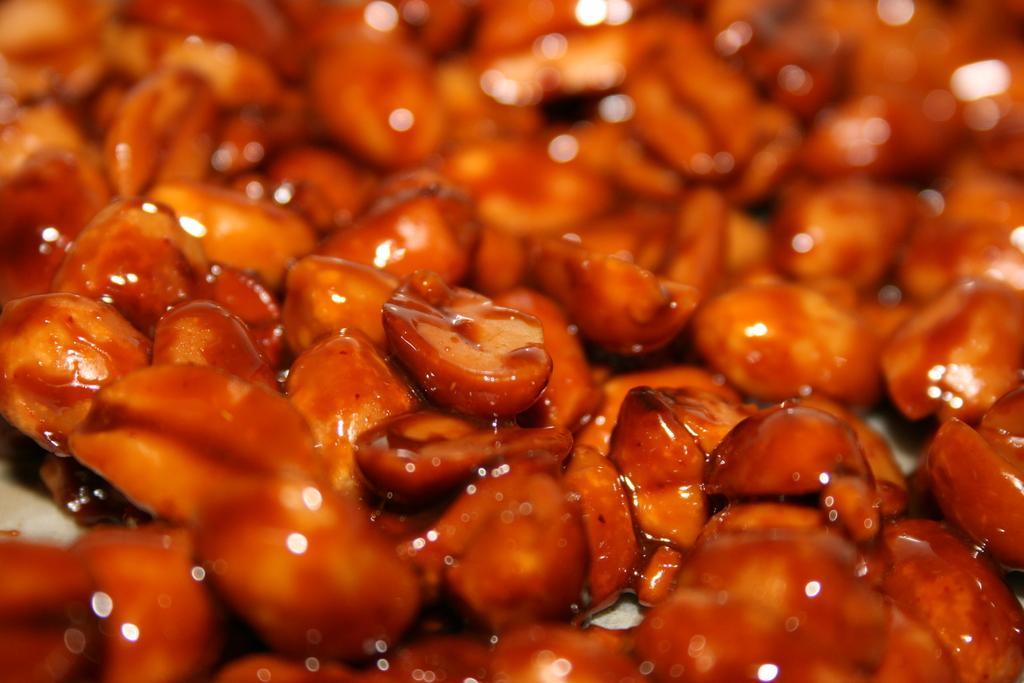Describe this image in one or two sentences. In the image there are caramelized peanuts. And there is a blur background. 